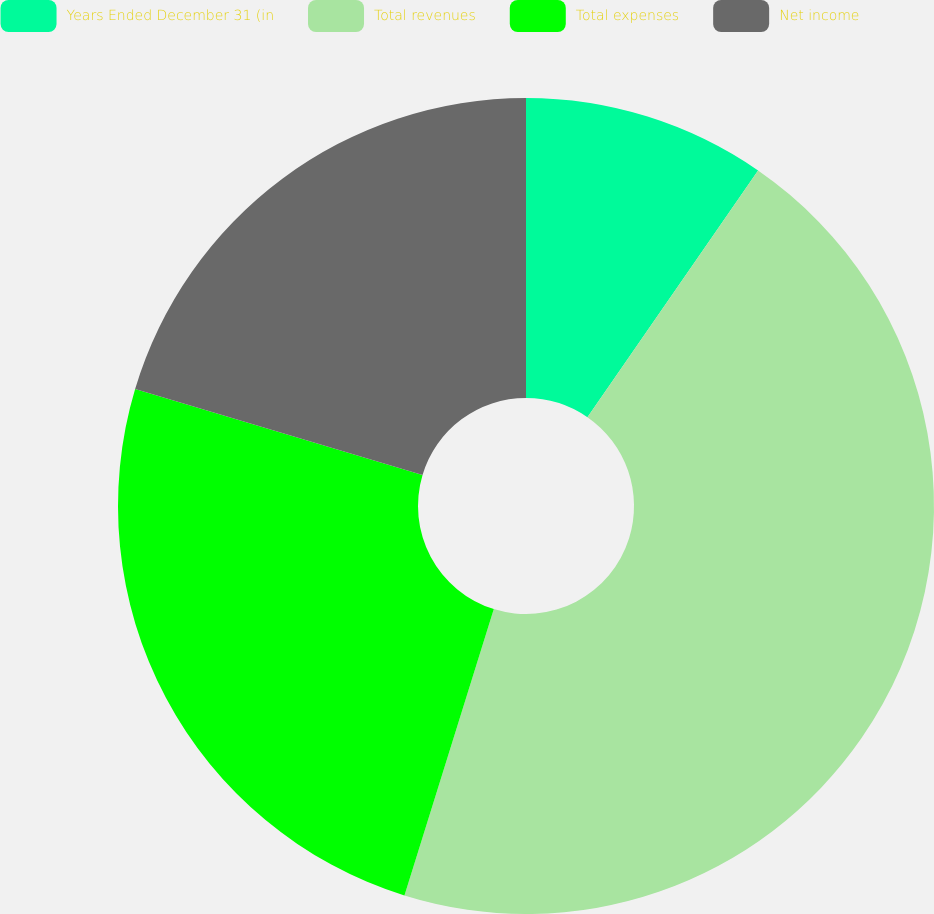Convert chart to OTSL. <chart><loc_0><loc_0><loc_500><loc_500><pie_chart><fcel>Years Ended December 31 (in<fcel>Total revenues<fcel>Total expenses<fcel>Net income<nl><fcel>9.63%<fcel>45.18%<fcel>24.81%<fcel>20.37%<nl></chart> 